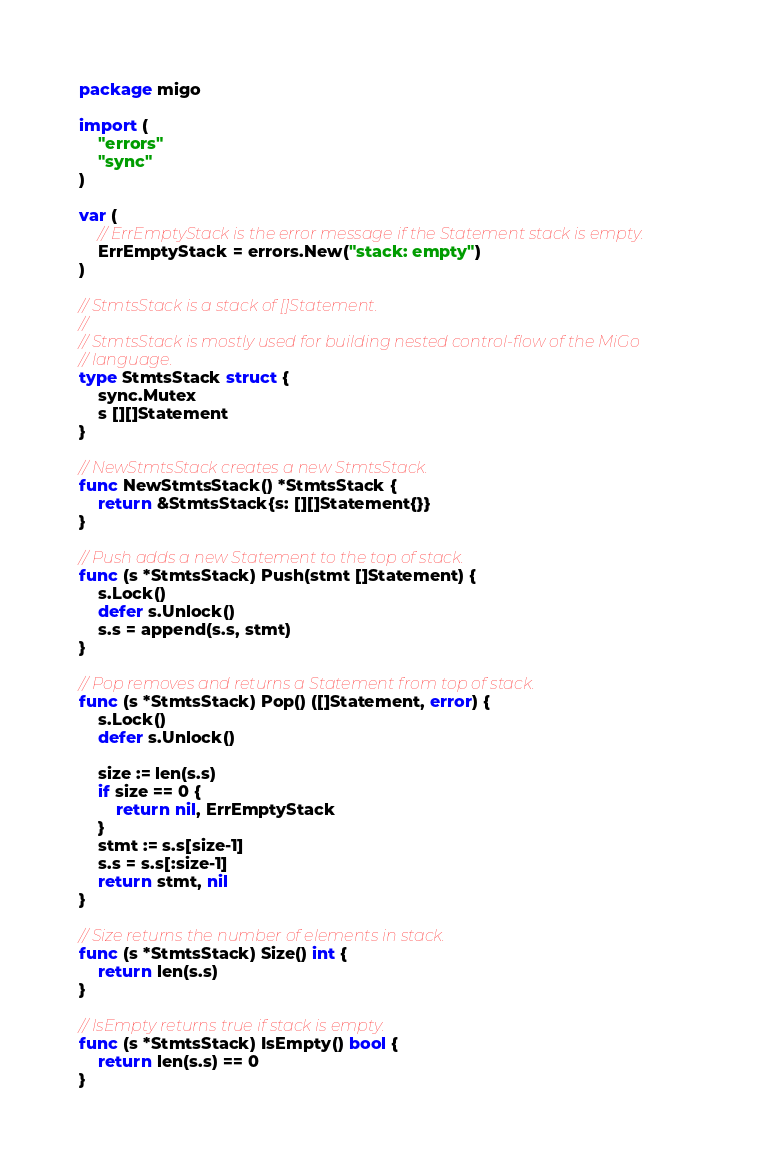<code> <loc_0><loc_0><loc_500><loc_500><_Go_>package migo

import (
	"errors"
	"sync"
)

var (
	// ErrEmptyStack is the error message if the Statement stack is empty.
	ErrEmptyStack = errors.New("stack: empty")
)

// StmtsStack is a stack of []Statement.
//
// StmtsStack is mostly used for building nested control-flow of the MiGo
// language.
type StmtsStack struct {
	sync.Mutex
	s [][]Statement
}

// NewStmtsStack creates a new StmtsStack.
func NewStmtsStack() *StmtsStack {
	return &StmtsStack{s: [][]Statement{}}
}

// Push adds a new Statement to the top of stack.
func (s *StmtsStack) Push(stmt []Statement) {
	s.Lock()
	defer s.Unlock()
	s.s = append(s.s, stmt)
}

// Pop removes and returns a Statement from top of stack.
func (s *StmtsStack) Pop() ([]Statement, error) {
	s.Lock()
	defer s.Unlock()

	size := len(s.s)
	if size == 0 {
		return nil, ErrEmptyStack
	}
	stmt := s.s[size-1]
	s.s = s.s[:size-1]
	return stmt, nil
}

// Size returns the number of elements in stack.
func (s *StmtsStack) Size() int {
	return len(s.s)
}

// IsEmpty returns true if stack is empty.
func (s *StmtsStack) IsEmpty() bool {
	return len(s.s) == 0
}
</code> 